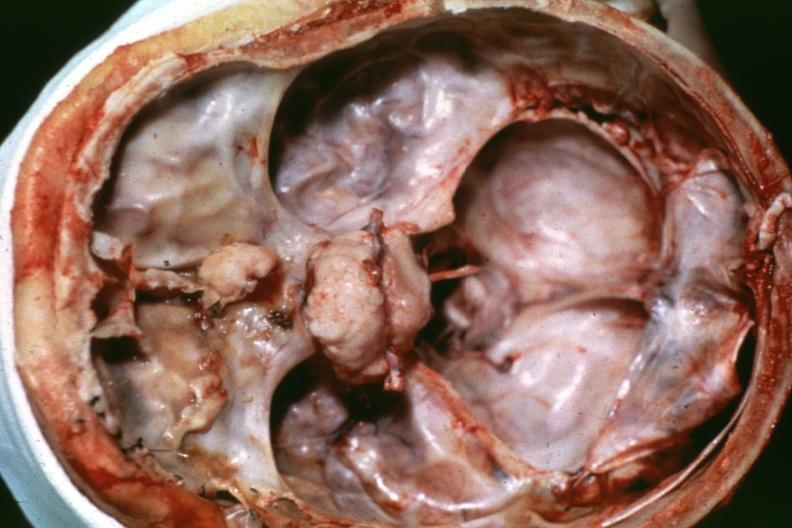what is present?
Answer the question using a single word or phrase. Bone 